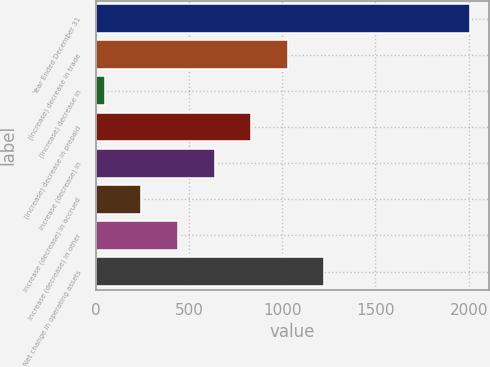Convert chart. <chart><loc_0><loc_0><loc_500><loc_500><bar_chart><fcel>Year Ended December 31<fcel>(Increase) decrease in trade<fcel>(Increase) decrease in<fcel>(Increase) decrease in prepaid<fcel>Increase (decrease) in<fcel>Increase (decrease) in accrued<fcel>Increase (decrease) in other<fcel>Net change in operating assets<nl><fcel>2009<fcel>1029.5<fcel>50<fcel>833.6<fcel>637.7<fcel>245.9<fcel>441.8<fcel>1225.4<nl></chart> 